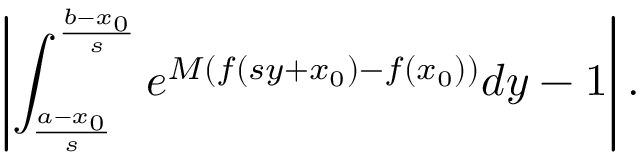Convert formula to latex. <formula><loc_0><loc_0><loc_500><loc_500>\left | \int _ { \frac { a - x _ { 0 } } { s } } ^ { \frac { b - x _ { 0 } } { s } } e ^ { M ( f ( s y + x _ { 0 } ) - f ( x _ { 0 } ) ) } d y - 1 \right | .</formula> 